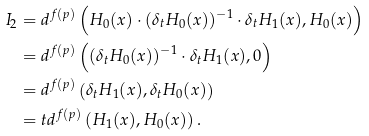<formula> <loc_0><loc_0><loc_500><loc_500>I _ { 2 } & = d ^ { f ( p ) } \left ( H _ { 0 } ( x ) \cdot ( \delta _ { t } H _ { 0 } ( x ) ) ^ { - 1 } \cdot \delta _ { t } H _ { 1 } ( x ) , H _ { 0 } ( x ) \right ) \\ & = d ^ { f ( p ) } \left ( ( \delta _ { t } H _ { 0 } ( x ) ) ^ { - 1 } \cdot \delta _ { t } H _ { 1 } ( x ) , 0 \right ) \\ & = d ^ { f ( p ) } \left ( \delta _ { t } H _ { 1 } ( x ) , \delta _ { t } H _ { 0 } ( x ) \right ) \\ & = t d ^ { f ( p ) } \left ( H _ { 1 } ( x ) , H _ { 0 } ( x ) \right ) .</formula> 